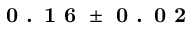Convert formula to latex. <formula><loc_0><loc_0><loc_500><loc_500>0 . 1 6 \pm 0 . 0 2</formula> 